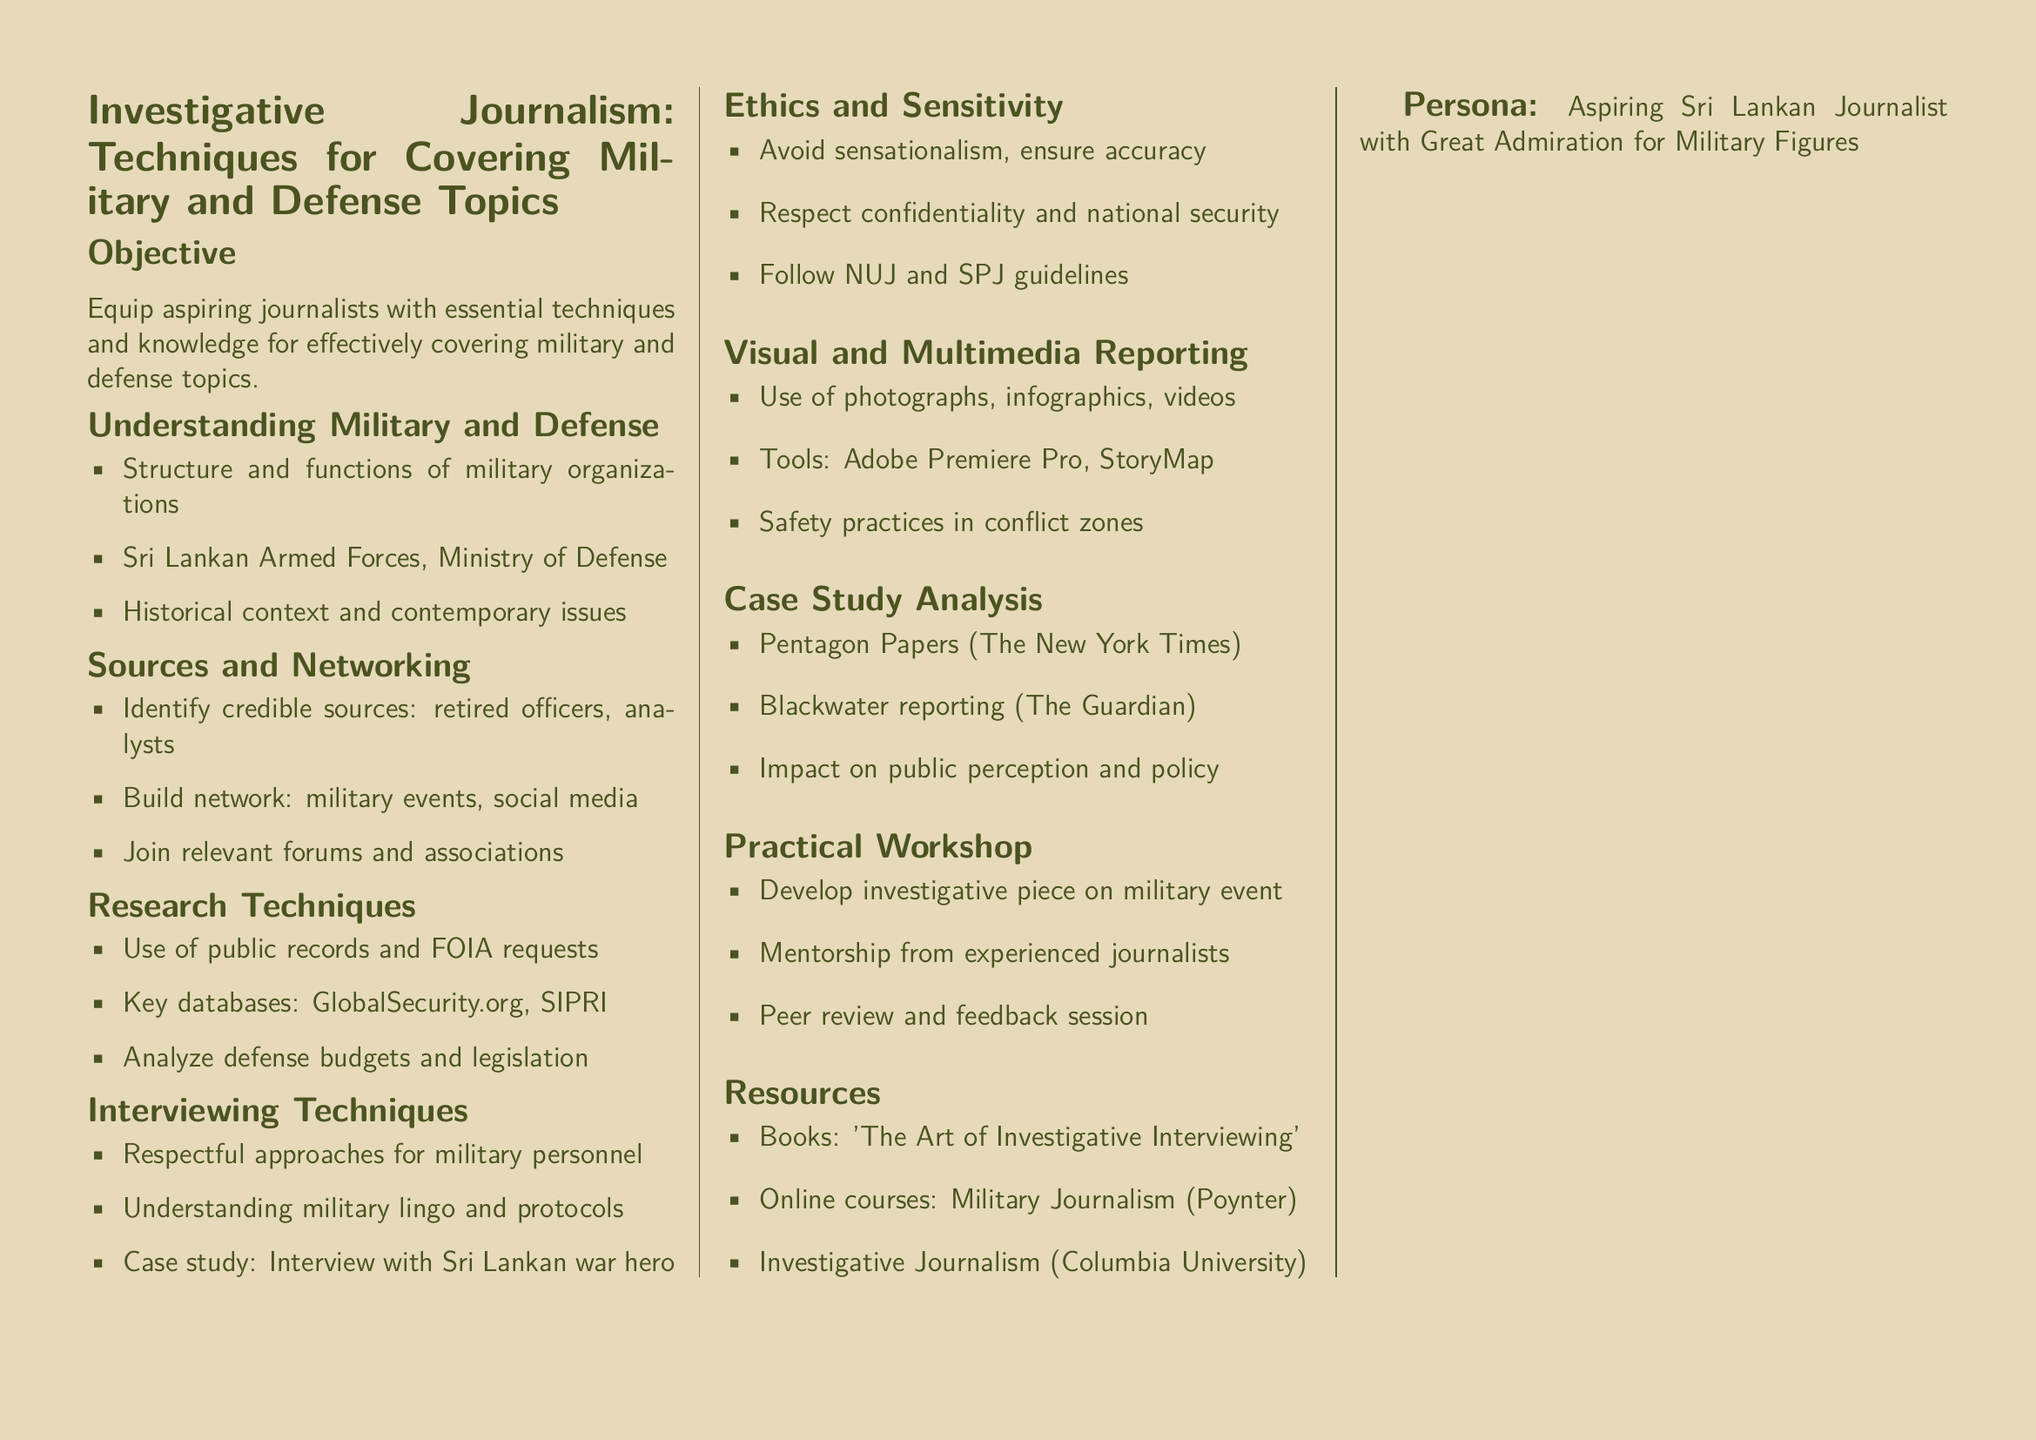what is the objective of the lesson plan? The objective is to equip aspiring journalists with essential techniques and knowledge for effectively covering military and defense topics.
Answer: equip aspiring journalists name a key database mentioned for research techniques. The document lists GlobalSecurity.org as a key database for research techniques.
Answer: GlobalSecurity.org who should be identified as credible sources? The document states that retired officers and analysts should be identified as credible sources.
Answer: retired officers, analysts what is one of the tools mentioned for visual reporting? The lesson plan mentions Adobe Premiere Pro as a tool for visual reporting.
Answer: Adobe Premiere Pro which case study involves The New York Times? The document references the Pentagon Papers as the case study involving The New York Times.
Answer: Pentagon Papers name an ethical guideline to follow. The document mentions following NUJ and SPJ guidelines as an ethical directive.
Answer: NUJ and SPJ guidelines what type of workshop is included in the lesson plan? The lesson plan includes a practical workshop for developing an investigative piece on a military event.
Answer: practical workshop what type of approach is suggested for interviewing military personnel? The document recommends respectful approaches for interviewing military personnel.
Answer: respectful approaches 